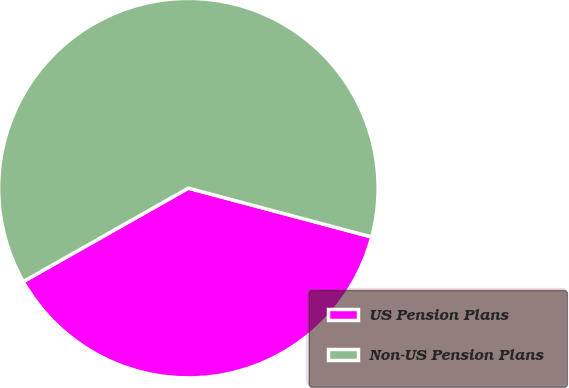Convert chart. <chart><loc_0><loc_0><loc_500><loc_500><pie_chart><fcel>US Pension Plans<fcel>Non-US Pension Plans<nl><fcel>37.66%<fcel>62.34%<nl></chart> 